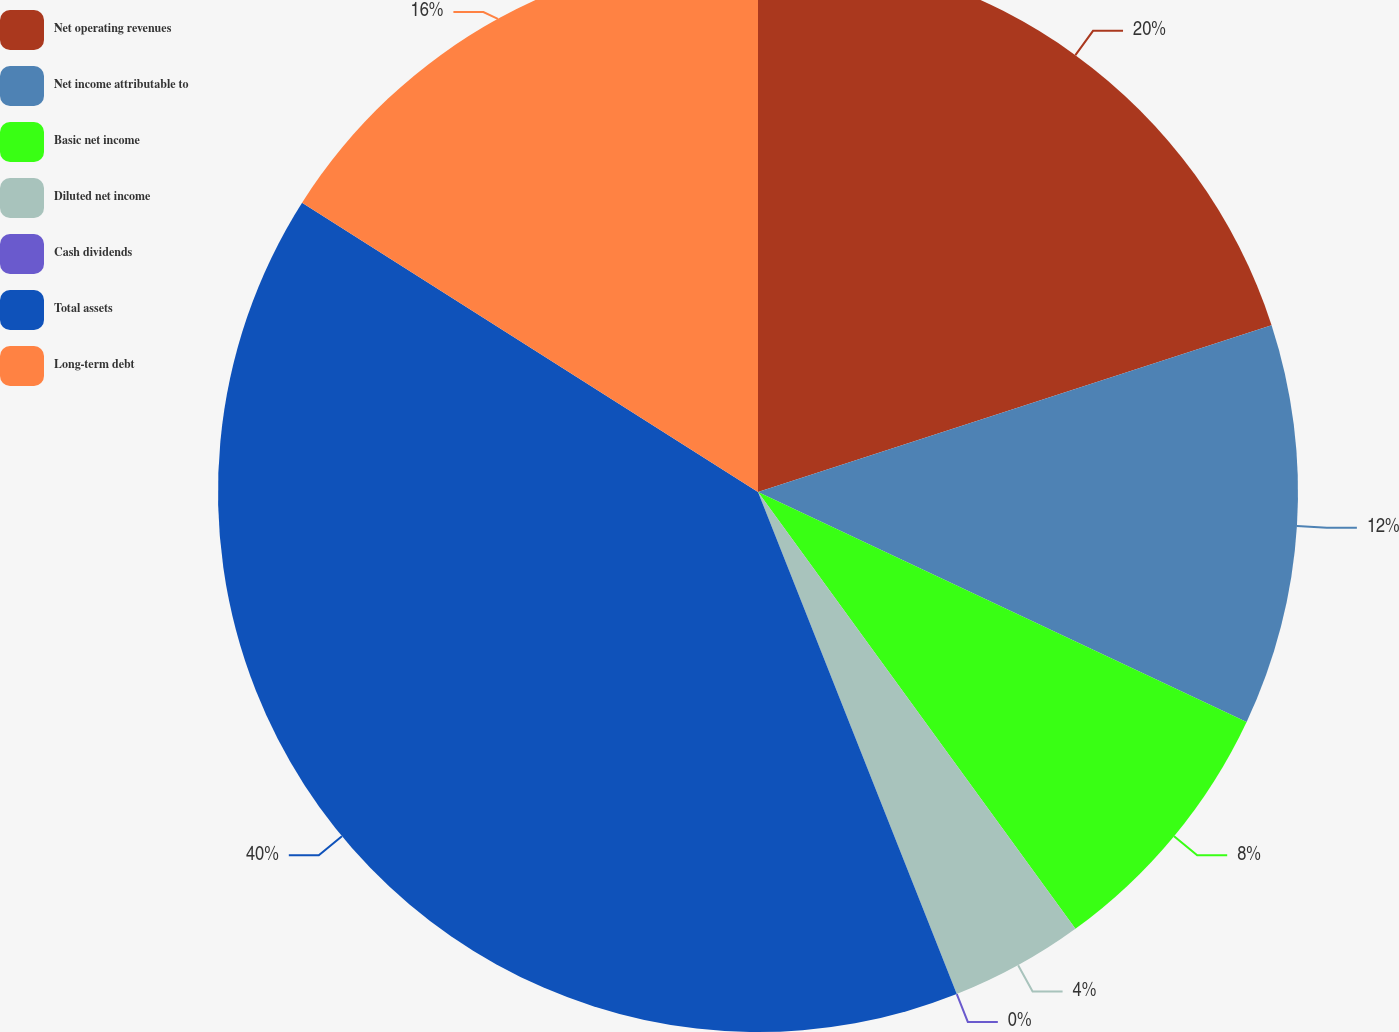Convert chart to OTSL. <chart><loc_0><loc_0><loc_500><loc_500><pie_chart><fcel>Net operating revenues<fcel>Net income attributable to<fcel>Basic net income<fcel>Diluted net income<fcel>Cash dividends<fcel>Total assets<fcel>Long-term debt<nl><fcel>20.0%<fcel>12.0%<fcel>8.0%<fcel>4.0%<fcel>0.0%<fcel>40.0%<fcel>16.0%<nl></chart> 